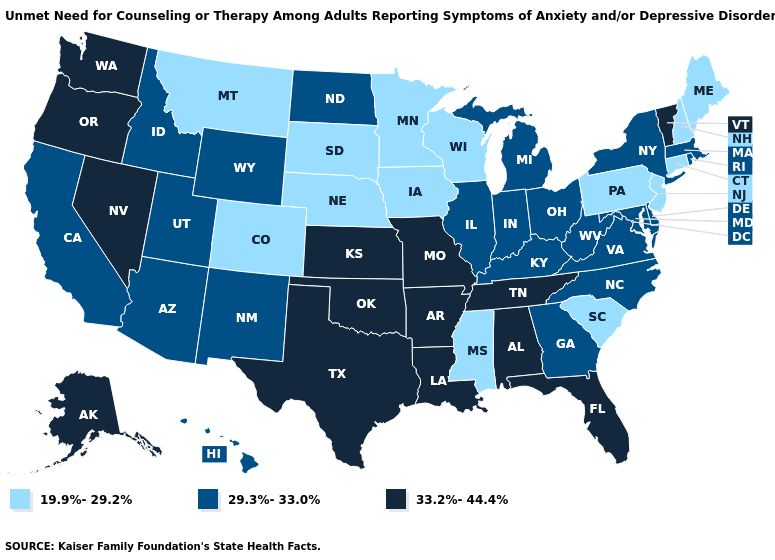Does Tennessee have the same value as Texas?
Quick response, please. Yes. Does California have the highest value in the USA?
Quick response, please. No. Which states have the lowest value in the USA?
Short answer required. Colorado, Connecticut, Iowa, Maine, Minnesota, Mississippi, Montana, Nebraska, New Hampshire, New Jersey, Pennsylvania, South Carolina, South Dakota, Wisconsin. What is the value of Massachusetts?
Short answer required. 29.3%-33.0%. What is the lowest value in states that border Mississippi?
Be succinct. 33.2%-44.4%. What is the highest value in the South ?
Give a very brief answer. 33.2%-44.4%. What is the value of Indiana?
Answer briefly. 29.3%-33.0%. How many symbols are there in the legend?
Quick response, please. 3. Which states have the lowest value in the USA?
Be succinct. Colorado, Connecticut, Iowa, Maine, Minnesota, Mississippi, Montana, Nebraska, New Hampshire, New Jersey, Pennsylvania, South Carolina, South Dakota, Wisconsin. Name the states that have a value in the range 29.3%-33.0%?
Give a very brief answer. Arizona, California, Delaware, Georgia, Hawaii, Idaho, Illinois, Indiana, Kentucky, Maryland, Massachusetts, Michigan, New Mexico, New York, North Carolina, North Dakota, Ohio, Rhode Island, Utah, Virginia, West Virginia, Wyoming. What is the lowest value in the USA?
Keep it brief. 19.9%-29.2%. Name the states that have a value in the range 19.9%-29.2%?
Give a very brief answer. Colorado, Connecticut, Iowa, Maine, Minnesota, Mississippi, Montana, Nebraska, New Hampshire, New Jersey, Pennsylvania, South Carolina, South Dakota, Wisconsin. What is the value of Iowa?
Give a very brief answer. 19.9%-29.2%. Does California have a higher value than Iowa?
Answer briefly. Yes. Which states have the highest value in the USA?
Be succinct. Alabama, Alaska, Arkansas, Florida, Kansas, Louisiana, Missouri, Nevada, Oklahoma, Oregon, Tennessee, Texas, Vermont, Washington. 